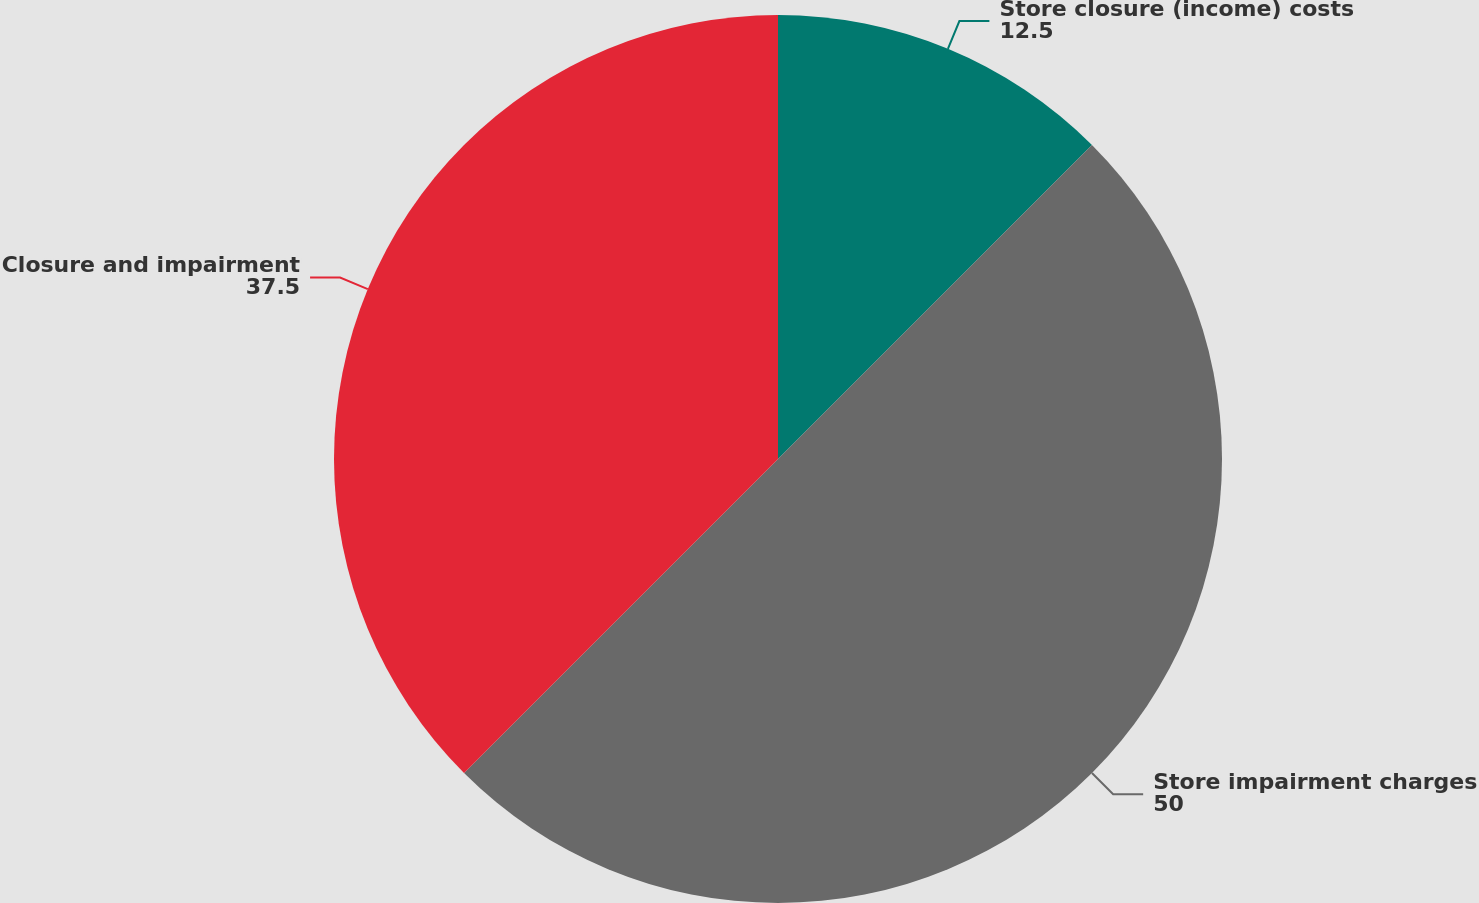Convert chart to OTSL. <chart><loc_0><loc_0><loc_500><loc_500><pie_chart><fcel>Store closure (income) costs<fcel>Store impairment charges<fcel>Closure and impairment<nl><fcel>12.5%<fcel>50.0%<fcel>37.5%<nl></chart> 